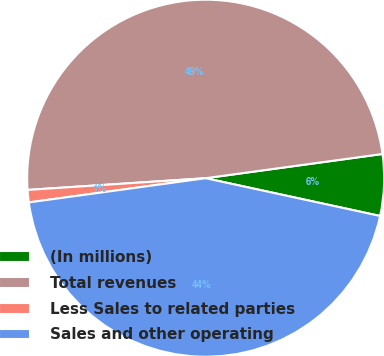<chart> <loc_0><loc_0><loc_500><loc_500><pie_chart><fcel>(In millions)<fcel>Total revenues<fcel>Less Sales to related parties<fcel>Sales and other operating<nl><fcel>5.56%<fcel>48.88%<fcel>1.12%<fcel>44.44%<nl></chart> 